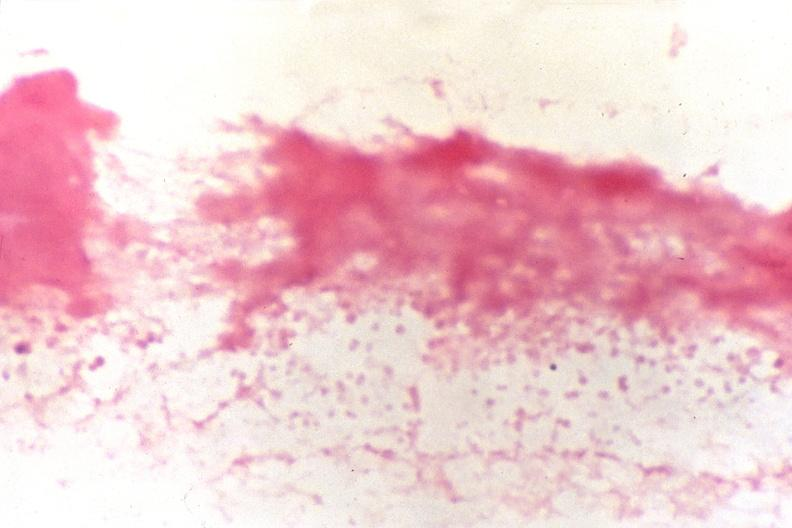what stain?
Answer the question using a single word or phrase. Gram negative cocci 